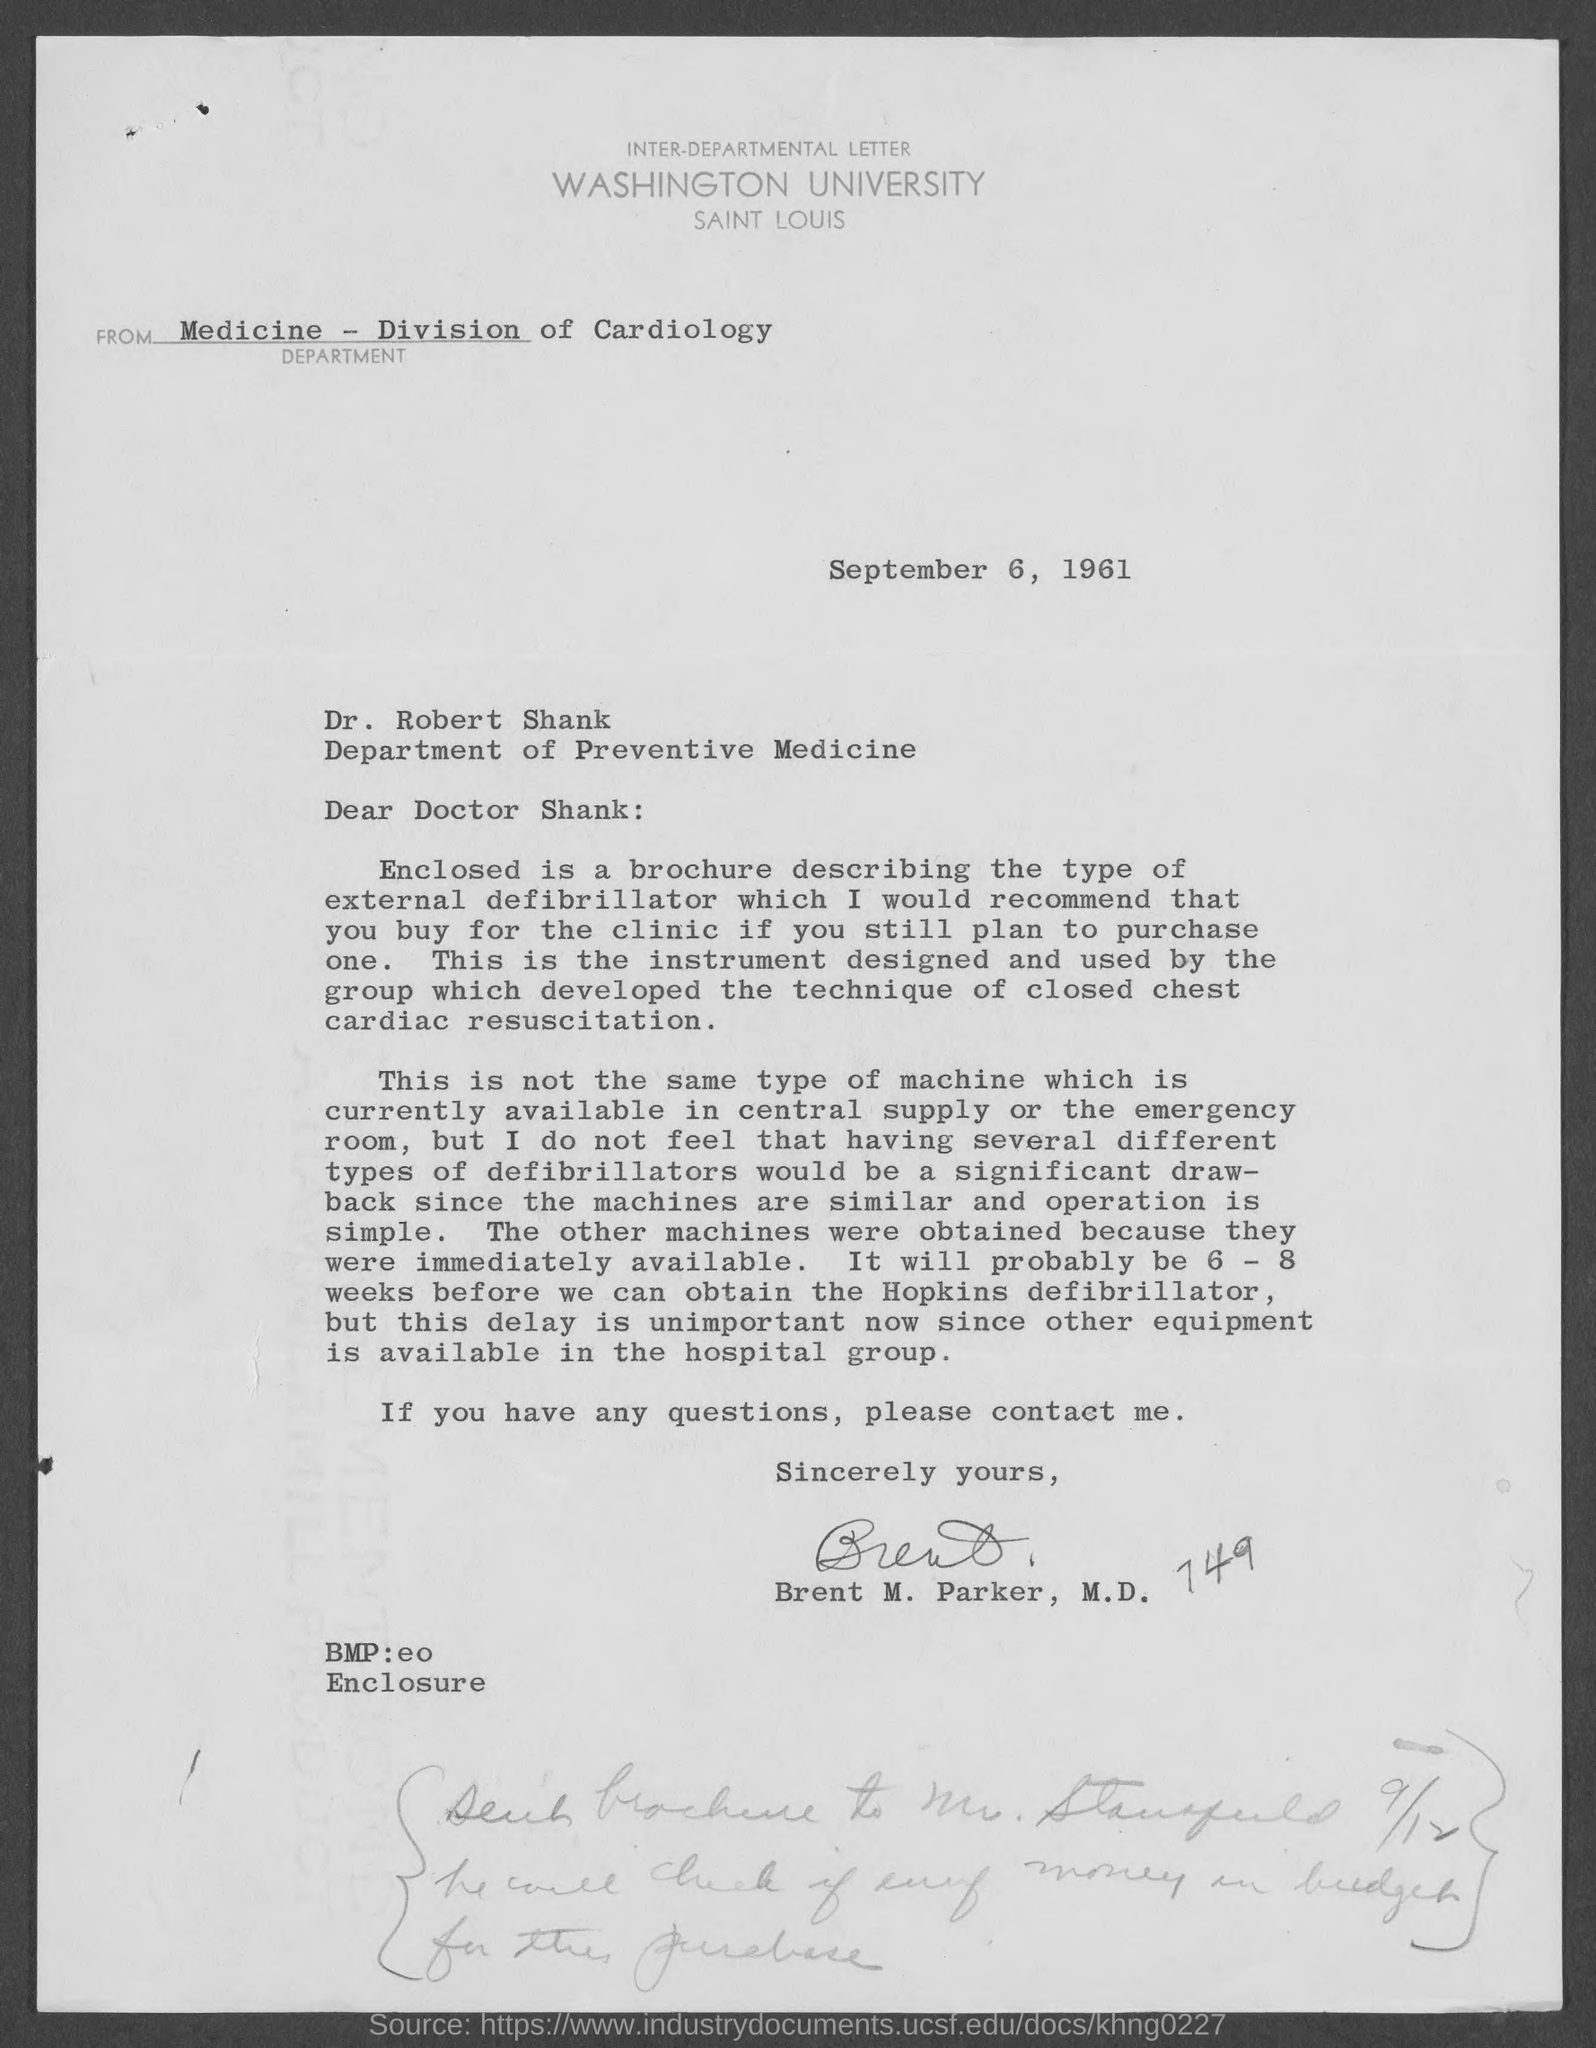What is the date mentioned in the given letter ?
Keep it short and to the point. SEPTEMBER 6, 1961. What is the name of the division mentioned in the given letter ?
Your answer should be very brief. DIVISION OF CARDIOLOGY. What is the name of the university mentioned in the given letter ?
Give a very brief answer. WASHINGTON UNIVERSITY. To whom this letter was written ?
Keep it short and to the point. DOCTOR SHANK. To which department dr. robert shank belongs to ?
Ensure brevity in your answer.  Department of preventive medicine. Who's sign was there at the end of the letter ?
Keep it short and to the point. BRENT M. PARKER. 